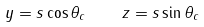<formula> <loc_0><loc_0><loc_500><loc_500>y = s \cos \theta _ { c } \quad z = s \sin \theta _ { c }</formula> 